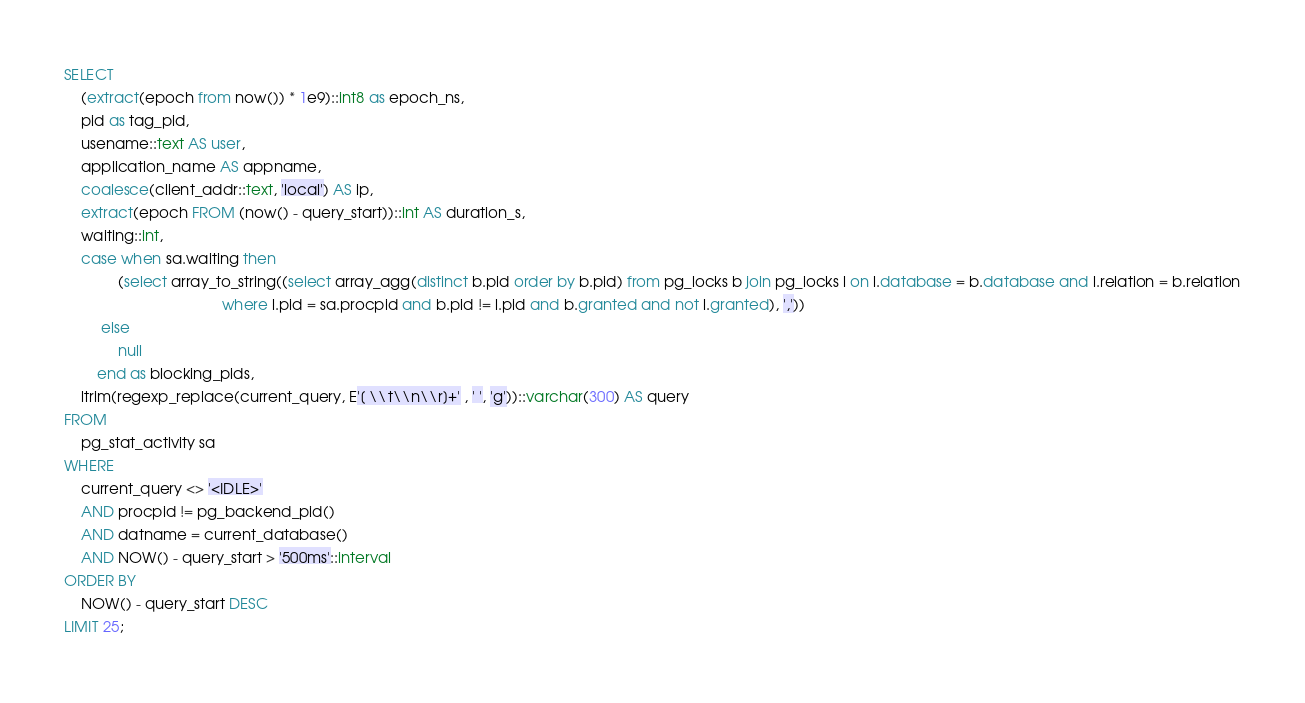Convert code to text. <code><loc_0><loc_0><loc_500><loc_500><_SQL_>SELECT
    (extract(epoch from now()) * 1e9)::int8 as epoch_ns,
    pid as tag_pid,
    usename::text AS user,
    application_name AS appname,
    coalesce(client_addr::text, 'local') AS ip,
    extract(epoch FROM (now() - query_start))::int AS duration_s,
    waiting::int,
    case when sa.waiting then
             (select array_to_string((select array_agg(distinct b.pid order by b.pid) from pg_locks b join pg_locks l on l.database = b.database and l.relation = b.relation
                                      where l.pid = sa.procpid and b.pid != l.pid and b.granted and not l.granted), ','))
         else
             null
        end as blocking_pids,
    ltrim(regexp_replace(current_query, E'[ \\t\\n\\r]+' , ' ', 'g'))::varchar(300) AS query
FROM
    pg_stat_activity sa
WHERE
    current_query <> '<IDLE>'
    AND procpid != pg_backend_pid()
    AND datname = current_database()
    AND NOW() - query_start > '500ms'::interval
ORDER BY
    NOW() - query_start DESC
LIMIT 25;
</code> 